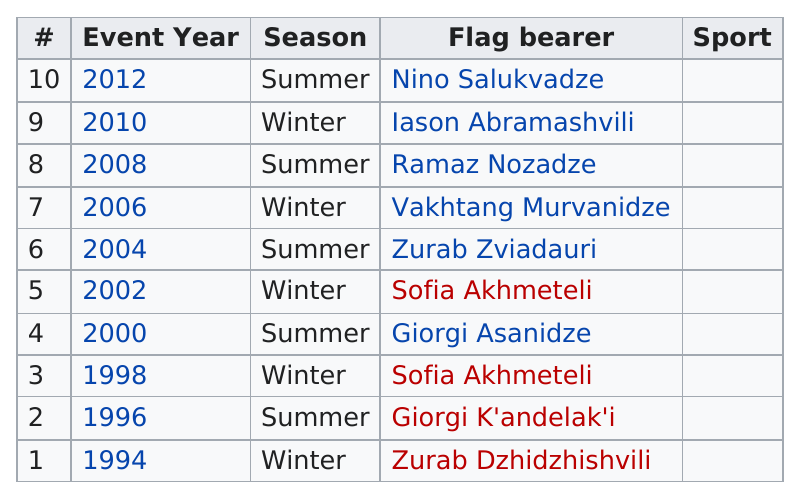Outline some significant characteristics in this image. There have been five summer flag bearers. Sofia Akhmeteli acted as flag bearer for Georgia in 9 consecutive Winter Olympics from 1994 to 2012. Sofia Akhmeteli was the first female flag bearer for Georgia in the Olympics. Giorgi K'andelak'i is a bearer with the first name Giorgi who is not Giorgi Asanidze. Nino Salukvadze was the last flag bearer. 